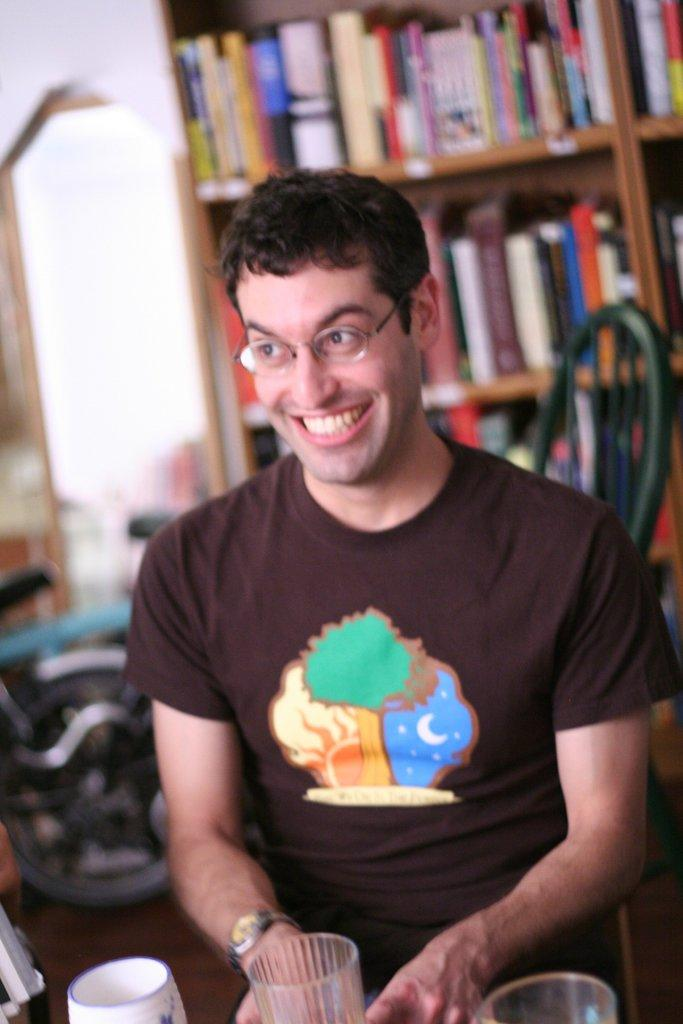What can be seen on the person's face in the image? There is a person with eyeglasses in the image. What is in front of the person in the image? There are objects in front of the person. What can be seen in the background of the image? There is a cupboard with books visible in the background of the image. How does the person's digestion process appear in the image? There is no indication of the person's digestion process in the image. What type of chicken is present in the image? There is no chicken present in the image. 